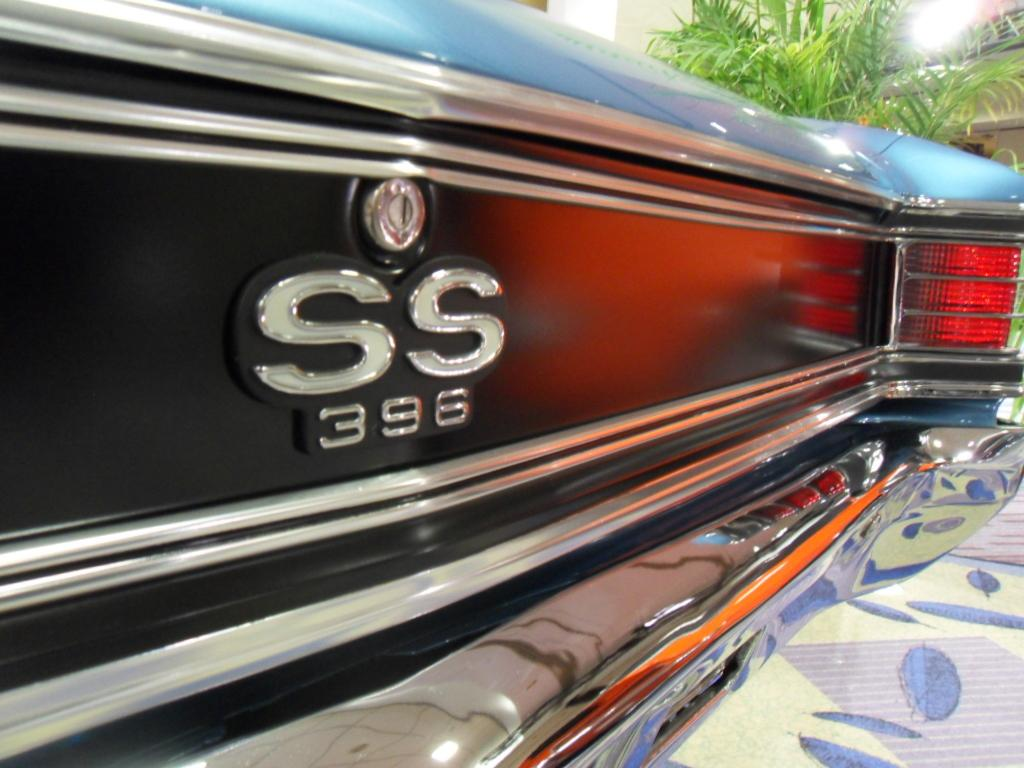What is the main subject of the image? The main subject of the image is a car. What specific feature can be seen on the car? The car has tail lights. Is there any branding or identification on the car? Yes, there is a logo attached to the car. What type of vegetation is present in the image? There is a plant with leaves in the image. What is the income of the ant crawling on the car in the image? There is no ant present in the image, so it is not possible to determine its income. 